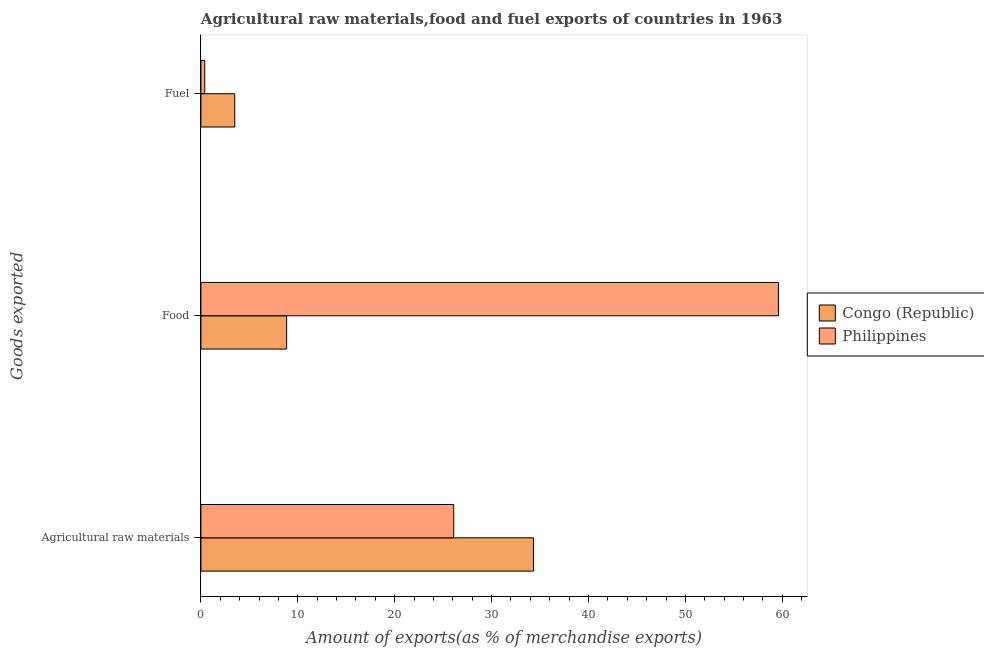How many bars are there on the 1st tick from the bottom?
Give a very brief answer. 2. What is the label of the 1st group of bars from the top?
Your answer should be very brief. Fuel. What is the percentage of fuel exports in Congo (Republic)?
Offer a very short reply. 3.49. Across all countries, what is the maximum percentage of food exports?
Provide a short and direct response. 59.6. Across all countries, what is the minimum percentage of fuel exports?
Offer a terse response. 0.4. In which country was the percentage of fuel exports maximum?
Make the answer very short. Congo (Republic). In which country was the percentage of food exports minimum?
Provide a short and direct response. Congo (Republic). What is the total percentage of food exports in the graph?
Your answer should be very brief. 68.45. What is the difference between the percentage of fuel exports in Philippines and that in Congo (Republic)?
Give a very brief answer. -3.09. What is the difference between the percentage of raw materials exports in Philippines and the percentage of food exports in Congo (Republic)?
Keep it short and to the point. 17.24. What is the average percentage of raw materials exports per country?
Provide a short and direct response. 30.21. What is the difference between the percentage of raw materials exports and percentage of fuel exports in Congo (Republic)?
Ensure brevity in your answer.  30.83. What is the ratio of the percentage of food exports in Philippines to that in Congo (Republic)?
Make the answer very short. 6.74. Is the difference between the percentage of fuel exports in Congo (Republic) and Philippines greater than the difference between the percentage of raw materials exports in Congo (Republic) and Philippines?
Ensure brevity in your answer.  No. What is the difference between the highest and the second highest percentage of food exports?
Provide a short and direct response. 50.76. What is the difference between the highest and the lowest percentage of raw materials exports?
Your response must be concise. 8.23. Is the sum of the percentage of fuel exports in Congo (Republic) and Philippines greater than the maximum percentage of raw materials exports across all countries?
Offer a very short reply. No. Is it the case that in every country, the sum of the percentage of raw materials exports and percentage of food exports is greater than the percentage of fuel exports?
Your answer should be very brief. Yes. What is the difference between two consecutive major ticks on the X-axis?
Offer a terse response. 10. Are the values on the major ticks of X-axis written in scientific E-notation?
Your response must be concise. No. Does the graph contain any zero values?
Ensure brevity in your answer.  No. Where does the legend appear in the graph?
Your response must be concise. Center right. How many legend labels are there?
Keep it short and to the point. 2. What is the title of the graph?
Your answer should be very brief. Agricultural raw materials,food and fuel exports of countries in 1963. What is the label or title of the X-axis?
Your answer should be compact. Amount of exports(as % of merchandise exports). What is the label or title of the Y-axis?
Give a very brief answer. Goods exported. What is the Amount of exports(as % of merchandise exports) of Congo (Republic) in Agricultural raw materials?
Provide a short and direct response. 34.32. What is the Amount of exports(as % of merchandise exports) in Philippines in Agricultural raw materials?
Give a very brief answer. 26.09. What is the Amount of exports(as % of merchandise exports) of Congo (Republic) in Food?
Give a very brief answer. 8.85. What is the Amount of exports(as % of merchandise exports) of Philippines in Food?
Offer a terse response. 59.6. What is the Amount of exports(as % of merchandise exports) of Congo (Republic) in Fuel?
Offer a very short reply. 3.49. What is the Amount of exports(as % of merchandise exports) of Philippines in Fuel?
Provide a short and direct response. 0.4. Across all Goods exported, what is the maximum Amount of exports(as % of merchandise exports) in Congo (Republic)?
Provide a succinct answer. 34.32. Across all Goods exported, what is the maximum Amount of exports(as % of merchandise exports) in Philippines?
Provide a succinct answer. 59.6. Across all Goods exported, what is the minimum Amount of exports(as % of merchandise exports) in Congo (Republic)?
Ensure brevity in your answer.  3.49. Across all Goods exported, what is the minimum Amount of exports(as % of merchandise exports) of Philippines?
Your response must be concise. 0.4. What is the total Amount of exports(as % of merchandise exports) in Congo (Republic) in the graph?
Give a very brief answer. 46.66. What is the total Amount of exports(as % of merchandise exports) in Philippines in the graph?
Make the answer very short. 86.09. What is the difference between the Amount of exports(as % of merchandise exports) in Congo (Republic) in Agricultural raw materials and that in Food?
Your answer should be compact. 25.47. What is the difference between the Amount of exports(as % of merchandise exports) of Philippines in Agricultural raw materials and that in Food?
Keep it short and to the point. -33.51. What is the difference between the Amount of exports(as % of merchandise exports) in Congo (Republic) in Agricultural raw materials and that in Fuel?
Your response must be concise. 30.83. What is the difference between the Amount of exports(as % of merchandise exports) of Philippines in Agricultural raw materials and that in Fuel?
Make the answer very short. 25.69. What is the difference between the Amount of exports(as % of merchandise exports) of Congo (Republic) in Food and that in Fuel?
Offer a very short reply. 5.36. What is the difference between the Amount of exports(as % of merchandise exports) in Philippines in Food and that in Fuel?
Provide a succinct answer. 59.21. What is the difference between the Amount of exports(as % of merchandise exports) of Congo (Republic) in Agricultural raw materials and the Amount of exports(as % of merchandise exports) of Philippines in Food?
Make the answer very short. -25.28. What is the difference between the Amount of exports(as % of merchandise exports) in Congo (Republic) in Agricultural raw materials and the Amount of exports(as % of merchandise exports) in Philippines in Fuel?
Your answer should be very brief. 33.92. What is the difference between the Amount of exports(as % of merchandise exports) in Congo (Republic) in Food and the Amount of exports(as % of merchandise exports) in Philippines in Fuel?
Make the answer very short. 8.45. What is the average Amount of exports(as % of merchandise exports) in Congo (Republic) per Goods exported?
Give a very brief answer. 15.55. What is the average Amount of exports(as % of merchandise exports) of Philippines per Goods exported?
Ensure brevity in your answer.  28.7. What is the difference between the Amount of exports(as % of merchandise exports) of Congo (Republic) and Amount of exports(as % of merchandise exports) of Philippines in Agricultural raw materials?
Give a very brief answer. 8.23. What is the difference between the Amount of exports(as % of merchandise exports) in Congo (Republic) and Amount of exports(as % of merchandise exports) in Philippines in Food?
Give a very brief answer. -50.76. What is the difference between the Amount of exports(as % of merchandise exports) of Congo (Republic) and Amount of exports(as % of merchandise exports) of Philippines in Fuel?
Make the answer very short. 3.09. What is the ratio of the Amount of exports(as % of merchandise exports) of Congo (Republic) in Agricultural raw materials to that in Food?
Your answer should be very brief. 3.88. What is the ratio of the Amount of exports(as % of merchandise exports) in Philippines in Agricultural raw materials to that in Food?
Provide a succinct answer. 0.44. What is the ratio of the Amount of exports(as % of merchandise exports) of Congo (Republic) in Agricultural raw materials to that in Fuel?
Provide a succinct answer. 9.83. What is the ratio of the Amount of exports(as % of merchandise exports) in Philippines in Agricultural raw materials to that in Fuel?
Offer a very short reply. 65.9. What is the ratio of the Amount of exports(as % of merchandise exports) in Congo (Republic) in Food to that in Fuel?
Make the answer very short. 2.53. What is the ratio of the Amount of exports(as % of merchandise exports) in Philippines in Food to that in Fuel?
Offer a terse response. 150.56. What is the difference between the highest and the second highest Amount of exports(as % of merchandise exports) of Congo (Republic)?
Provide a succinct answer. 25.47. What is the difference between the highest and the second highest Amount of exports(as % of merchandise exports) of Philippines?
Your answer should be compact. 33.51. What is the difference between the highest and the lowest Amount of exports(as % of merchandise exports) of Congo (Republic)?
Ensure brevity in your answer.  30.83. What is the difference between the highest and the lowest Amount of exports(as % of merchandise exports) in Philippines?
Offer a terse response. 59.21. 